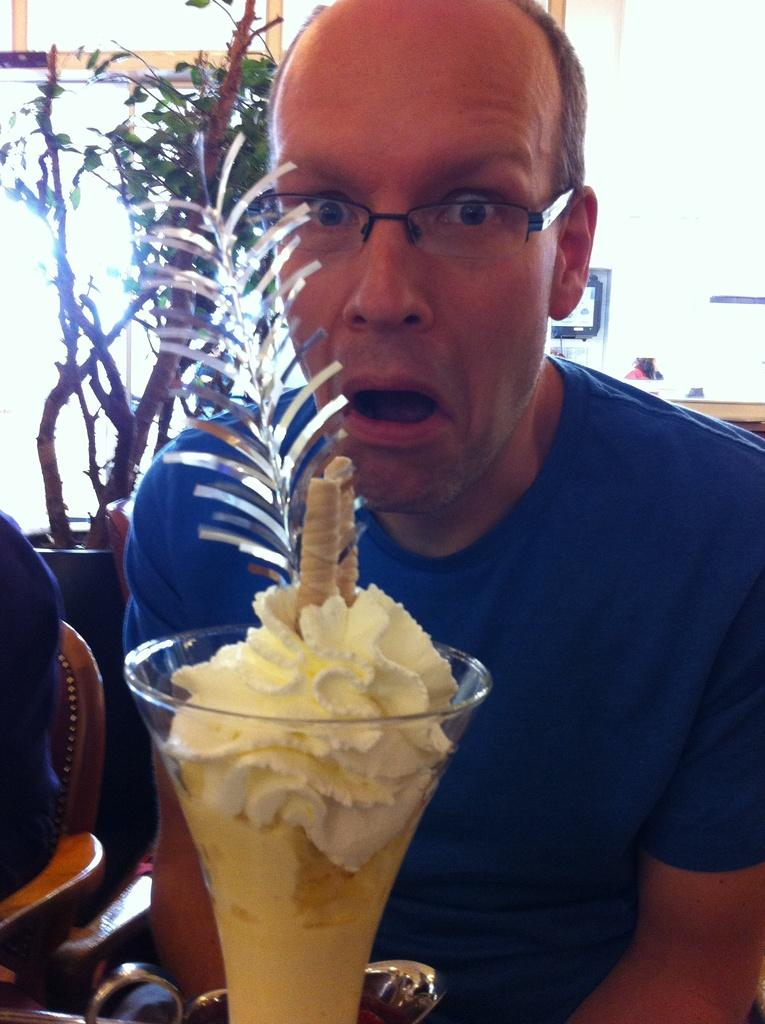Who or what is the main subject in the image? There is a person in the image. What is the person interacting with in the image? There is a glass with ice cream in front of the person. What can be seen in the background of the image? There is a house plant, frames, and a wall visible in the background of the image. How many birds are sitting on the drawer in the image? There is no drawer or birds present in the image. What season is depicted in the image, considering the presence of ice cream? The image does not provide any specific information about the season; however, ice cream is often associated with summer, but this cannot be confirmed from the image alone. 